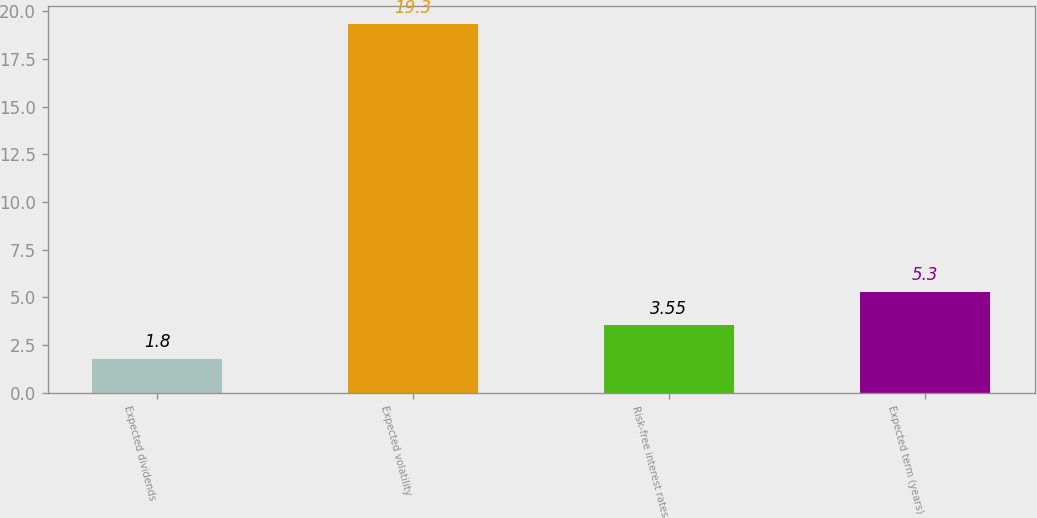<chart> <loc_0><loc_0><loc_500><loc_500><bar_chart><fcel>Expected dividends<fcel>Expected volatility<fcel>Risk-free interest rates<fcel>Expected term (years)<nl><fcel>1.8<fcel>19.3<fcel>3.55<fcel>5.3<nl></chart> 